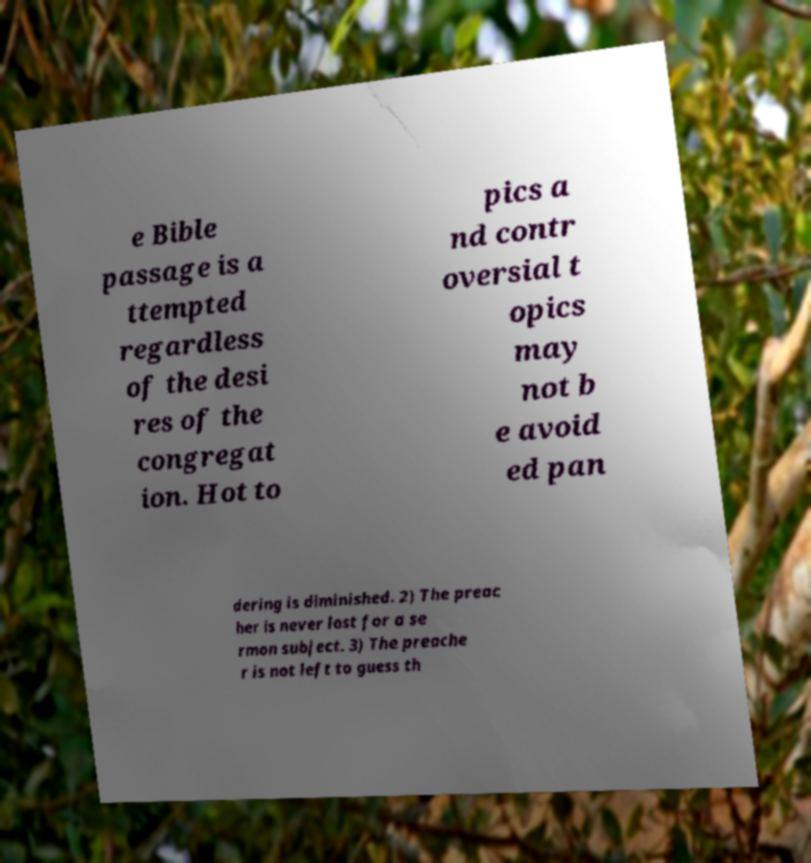For documentation purposes, I need the text within this image transcribed. Could you provide that? e Bible passage is a ttempted regardless of the desi res of the congregat ion. Hot to pics a nd contr oversial t opics may not b e avoid ed pan dering is diminished. 2) The preac her is never lost for a se rmon subject. 3) The preache r is not left to guess th 